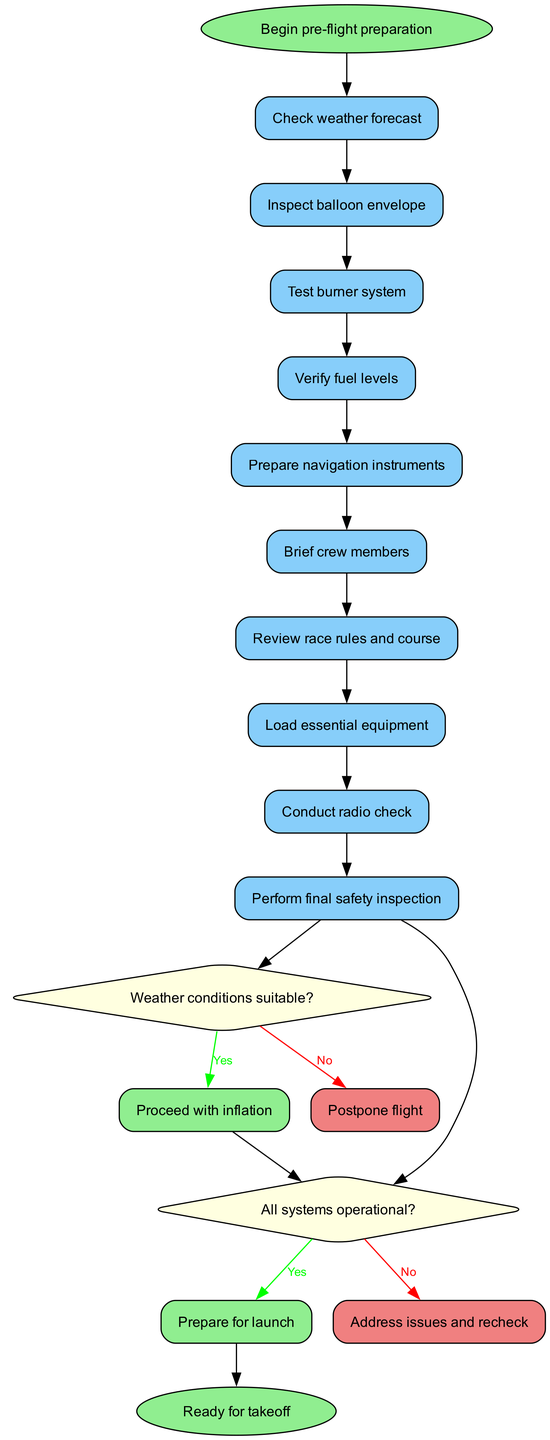What is the first action in the preparation process? The first action listed in the diagram is "Check weather forecast." This is clearly indicated as the first step following the start node.
Answer: Check weather forecast How many decisions are made during the pre-flight preparation process? There are two decisions made in the diagram: one regarding the suitability of weather conditions and another about the operational status of systems. This can be counted directly from the decision nodes present.
Answer: 2 What is the final outcome of the diagram? The final outcome is stated as "Ready for takeoff," which is represented in the end node of the diagram. This can be identified directly from the terminal node connected to the last yes branch.
Answer: Ready for takeoff What happens if the weather conditions are not suitable? If the weather conditions are not suitable, the process leads to the action "Postpone flight," as represented in the no branch of the first decision. This shows the alternative route when conditions are not met.
Answer: Postpone flight What action occurs after verifying fuel levels? After verifying fuel levels, the next action is "Prepare navigation instruments." This is determined by following the sequence of actions listed in the diagram where each action flows to the next.
Answer: Prepare navigation instruments What must be completed before preparing for launch? Before preparing for launch, all systems must be operational, as indicated by the second decision node that leads to this preparation step based on the yes response.
Answer: All systems operational Which action is performed immediately before conducting a radio check? The action performed immediately before conducting a radio check is "Brief crew members." This can be seen by tracing the sequence of actions leading up to the radio check.
Answer: Brief crew members What indicates that the pilot has completed the pre-flight preparation process? The completion of the pre-flight preparation process is indicated by the end node, stating "Ready for takeoff." It shows the successful conclusion of all necessary steps and checks.
Answer: Ready for takeoff 